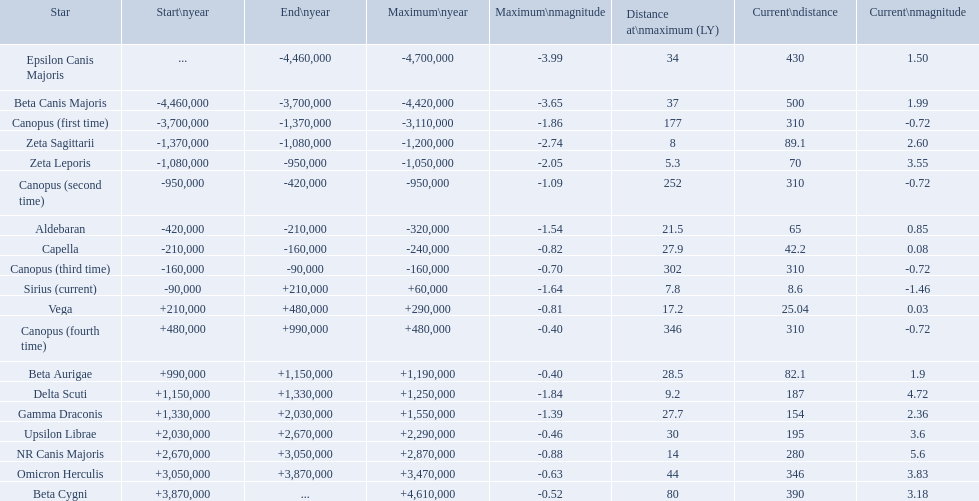What are the historical brightest stars? Epsilon Canis Majoris, Beta Canis Majoris, Canopus (first time), Zeta Sagittarii, Zeta Leporis, Canopus (second time), Aldebaran, Capella, Canopus (third time), Sirius (current), Vega, Canopus (fourth time), Beta Aurigae, Delta Scuti, Gamma Draconis, Upsilon Librae, NR Canis Majoris, Omicron Herculis, Beta Cygni. Of those which star has a distance at maximum of 80 Beta Cygni. What are the historically most luminous stars? Epsilon Canis Majoris, Beta Canis Majoris, Canopus (first time), Zeta Sagittarii, Zeta Leporis, Canopus (second time), Aldebaran, Capella, Canopus (third time), Sirius (current), Vega, Canopus (fourth time), Beta Aurigae, Delta Scuti, Gamma Draconis, Upsilon Librae, NR Canis Majoris, Omicron Herculis, Beta Cygni. Among them, which star has a maximum distance of 80? Beta Cygni. What are the historically most brilliant stars? Epsilon Canis Majoris, Beta Canis Majoris, Canopus (first time), Zeta Sagittarii, Zeta Leporis, Canopus (second time), Aldebaran, Capella, Canopus (third time), Sirius (current), Vega, Canopus (fourth time), Beta Aurigae, Delta Scuti, Gamma Draconis, Upsilon Librae, NR Canis Majoris, Omicron Herculis, Beta Cygni. Out of those, which star has a distance not exceeding 80? Beta Cygni. What are the past brightest stars? Epsilon Canis Majoris, Beta Canis Majoris, Canopus (first time), Zeta Sagittarii, Zeta Leporis, Canopus (second time), Aldebaran, Capella, Canopus (third time), Sirius (current), Vega, Canopus (fourth time), Beta Aurigae, Delta Scuti, Gamma Draconis, Upsilon Librae, NR Canis Majoris, Omicron Herculis, Beta Cygni. From those, which star has a distance up to 80? Beta Cygni. 